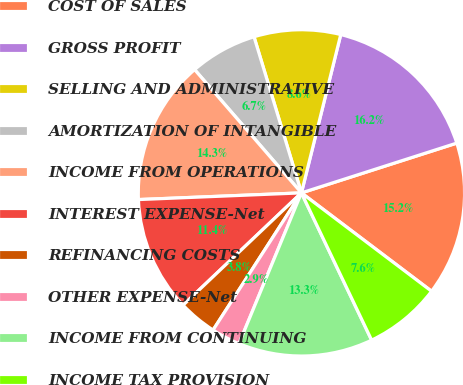Convert chart. <chart><loc_0><loc_0><loc_500><loc_500><pie_chart><fcel>COST OF SALES<fcel>GROSS PROFIT<fcel>SELLING AND ADMINISTRATIVE<fcel>AMORTIZATION OF INTANGIBLE<fcel>INCOME FROM OPERATIONS<fcel>INTEREST EXPENSE-Net<fcel>REFINANCING COSTS<fcel>OTHER EXPENSE-Net<fcel>INCOME FROM CONTINUING<fcel>INCOME TAX PROVISION<nl><fcel>15.24%<fcel>16.19%<fcel>8.57%<fcel>6.67%<fcel>14.29%<fcel>11.43%<fcel>3.81%<fcel>2.86%<fcel>13.33%<fcel>7.62%<nl></chart> 